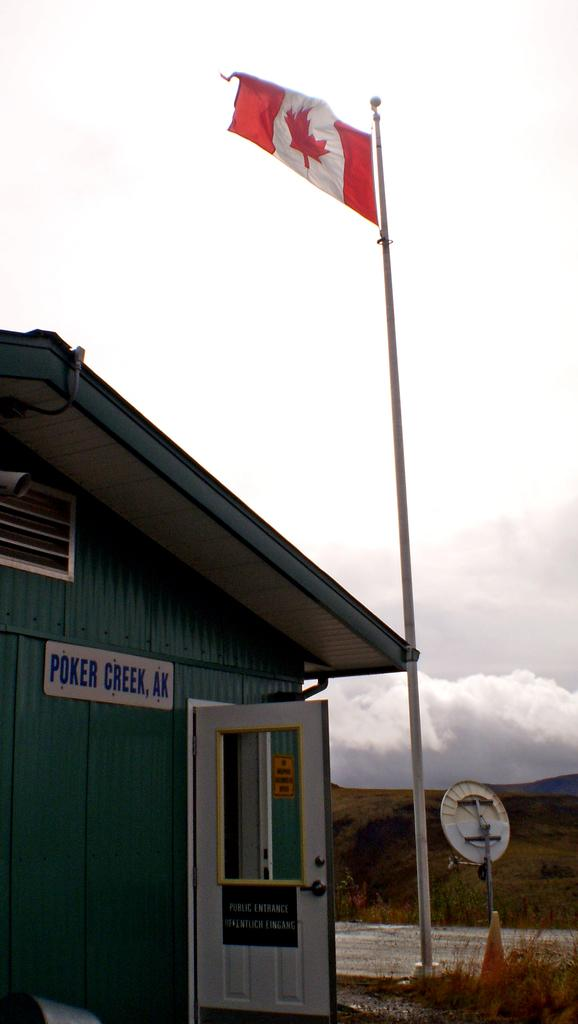What type of structure is present in the image? There is a house in the image. What feature can be seen on the house? The house has a flagpole. What natural feature is visible in the background of the image? There is a mountain in the background of the image. What else can be seen in the background of the image? The sky is visible in the background of the image. What type of notebook is being used by the person in the scene? There is no person or notebook present in the image; it only features a house, a flagpole, a mountain, and the sky. 